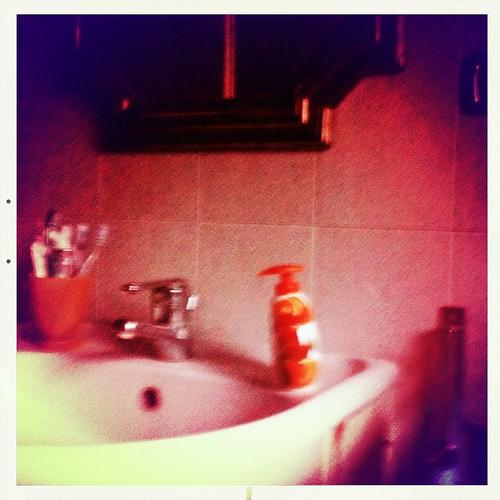Question: what side of the sink is the soap on?
Choices:
A. Right.
B. On the left.
C. The back.
D. On the counter side.
Answer with the letter. Answer: A Question: what side of the sink is the cup on?
Choices:
A. On the right.
B. On the center.
C. Left.
D. On the back.
Answer with the letter. Answer: C Question: where was this picture taken?
Choices:
A. Bathroom.
B. Kitchen.
C. School.
D. Park.
Answer with the letter. Answer: A Question: how many soap dispensers are there?
Choices:
A. Two.
B. One.
C. Three.
D. Four.
Answer with the letter. Answer: B Question: what color is the soap?
Choices:
A. White.
B. Orange.
C. Blue.
D. Green.
Answer with the letter. Answer: B 